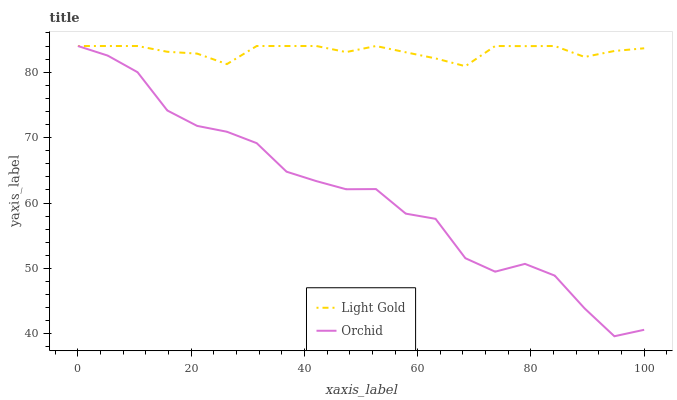Does Orchid have the minimum area under the curve?
Answer yes or no. Yes. Does Light Gold have the maximum area under the curve?
Answer yes or no. Yes. Does Orchid have the maximum area under the curve?
Answer yes or no. No. Is Light Gold the smoothest?
Answer yes or no. Yes. Is Orchid the roughest?
Answer yes or no. Yes. Is Orchid the smoothest?
Answer yes or no. No. Does Orchid have the lowest value?
Answer yes or no. Yes. Does Orchid have the highest value?
Answer yes or no. Yes. Does Orchid intersect Light Gold?
Answer yes or no. Yes. Is Orchid less than Light Gold?
Answer yes or no. No. Is Orchid greater than Light Gold?
Answer yes or no. No. 